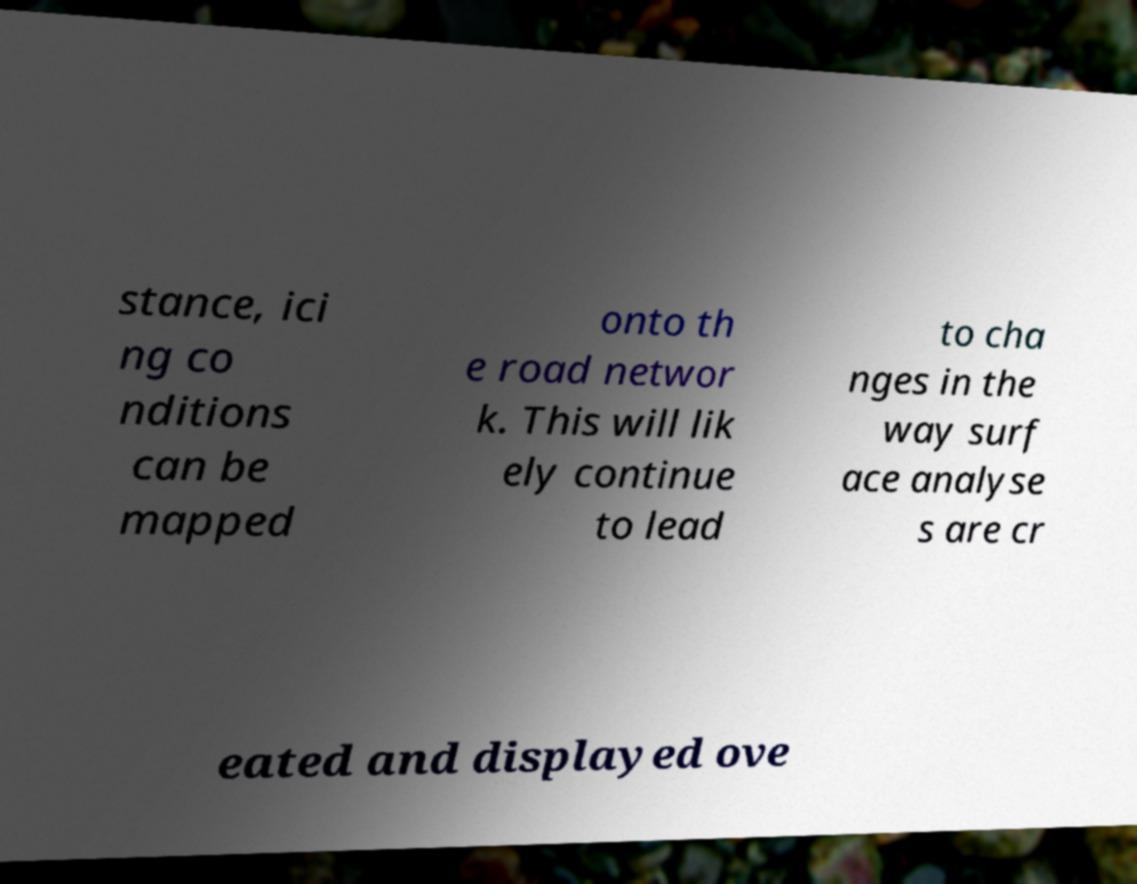Please identify and transcribe the text found in this image. stance, ici ng co nditions can be mapped onto th e road networ k. This will lik ely continue to lead to cha nges in the way surf ace analyse s are cr eated and displayed ove 